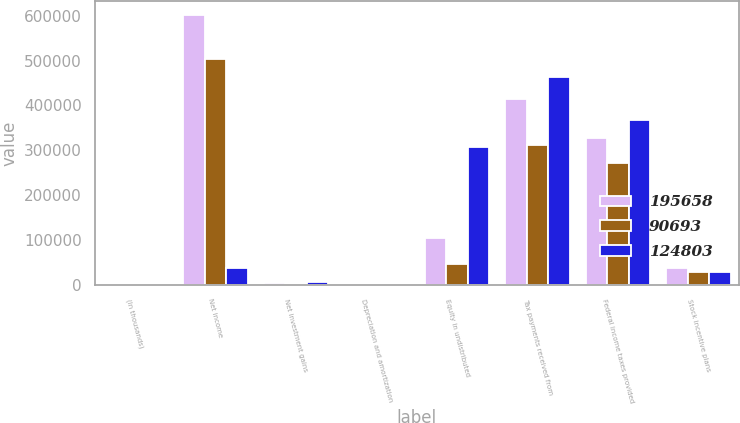Convert chart. <chart><loc_0><loc_0><loc_500><loc_500><stacked_bar_chart><ecel><fcel>(In thousands)<fcel>Net income<fcel>Net investment gains<fcel>Depreciation and amortization<fcel>Equity in undistributed<fcel>Tax payments received from<fcel>Federal income taxes provided<fcel>Stock incentive plans<nl><fcel>195658<fcel>2016<fcel>601919<fcel>3649<fcel>2744<fcel>103944<fcel>414386<fcel>327520<fcel>37174<nl><fcel>90693<fcel>2015<fcel>503694<fcel>696<fcel>2693<fcel>46113<fcel>311482<fcel>272180<fcel>29725<nl><fcel>124803<fcel>2014<fcel>37174<fcel>5487<fcel>2916<fcel>307401<fcel>462809<fcel>366721<fcel>28068<nl></chart> 